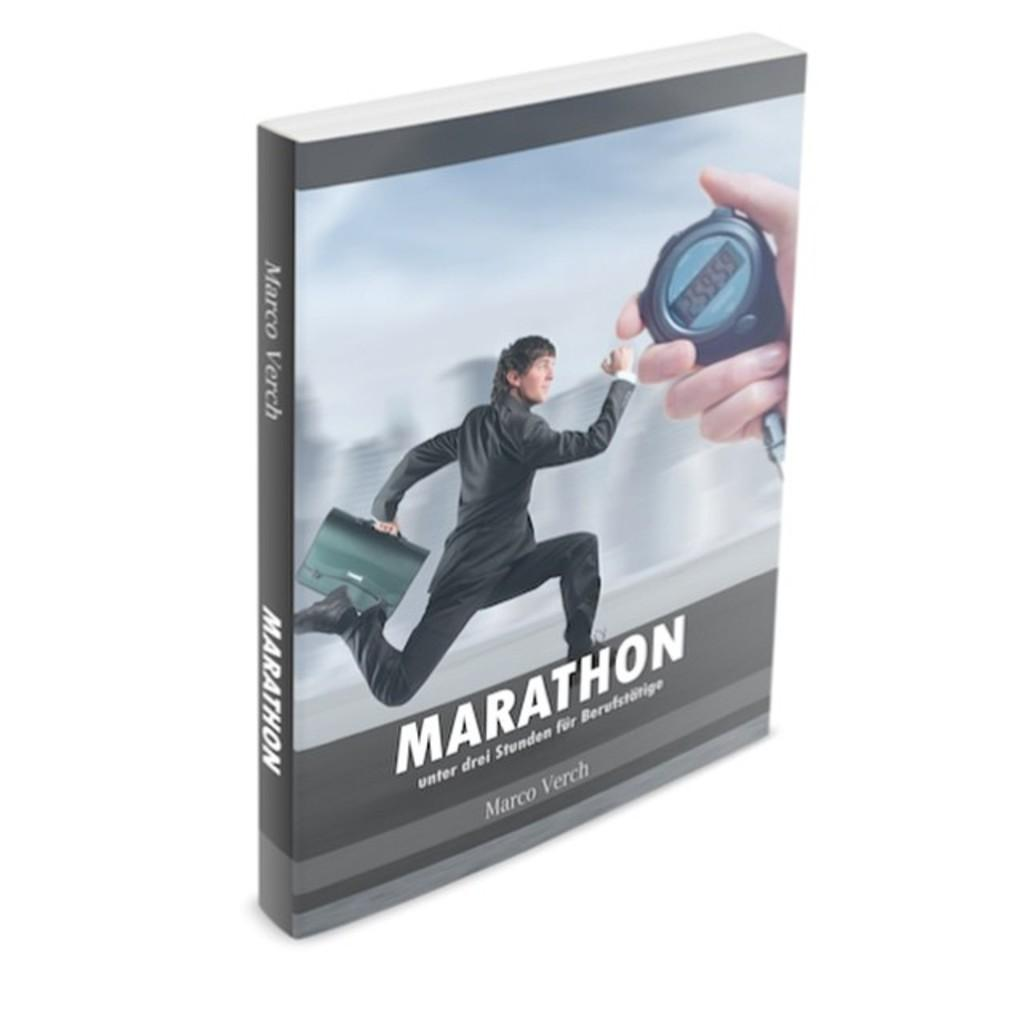<image>
Relay a brief, clear account of the picture shown. A book called MARATHON with a picture of a man in a suit running with a briefcase with a hand holding a stopwatch. 